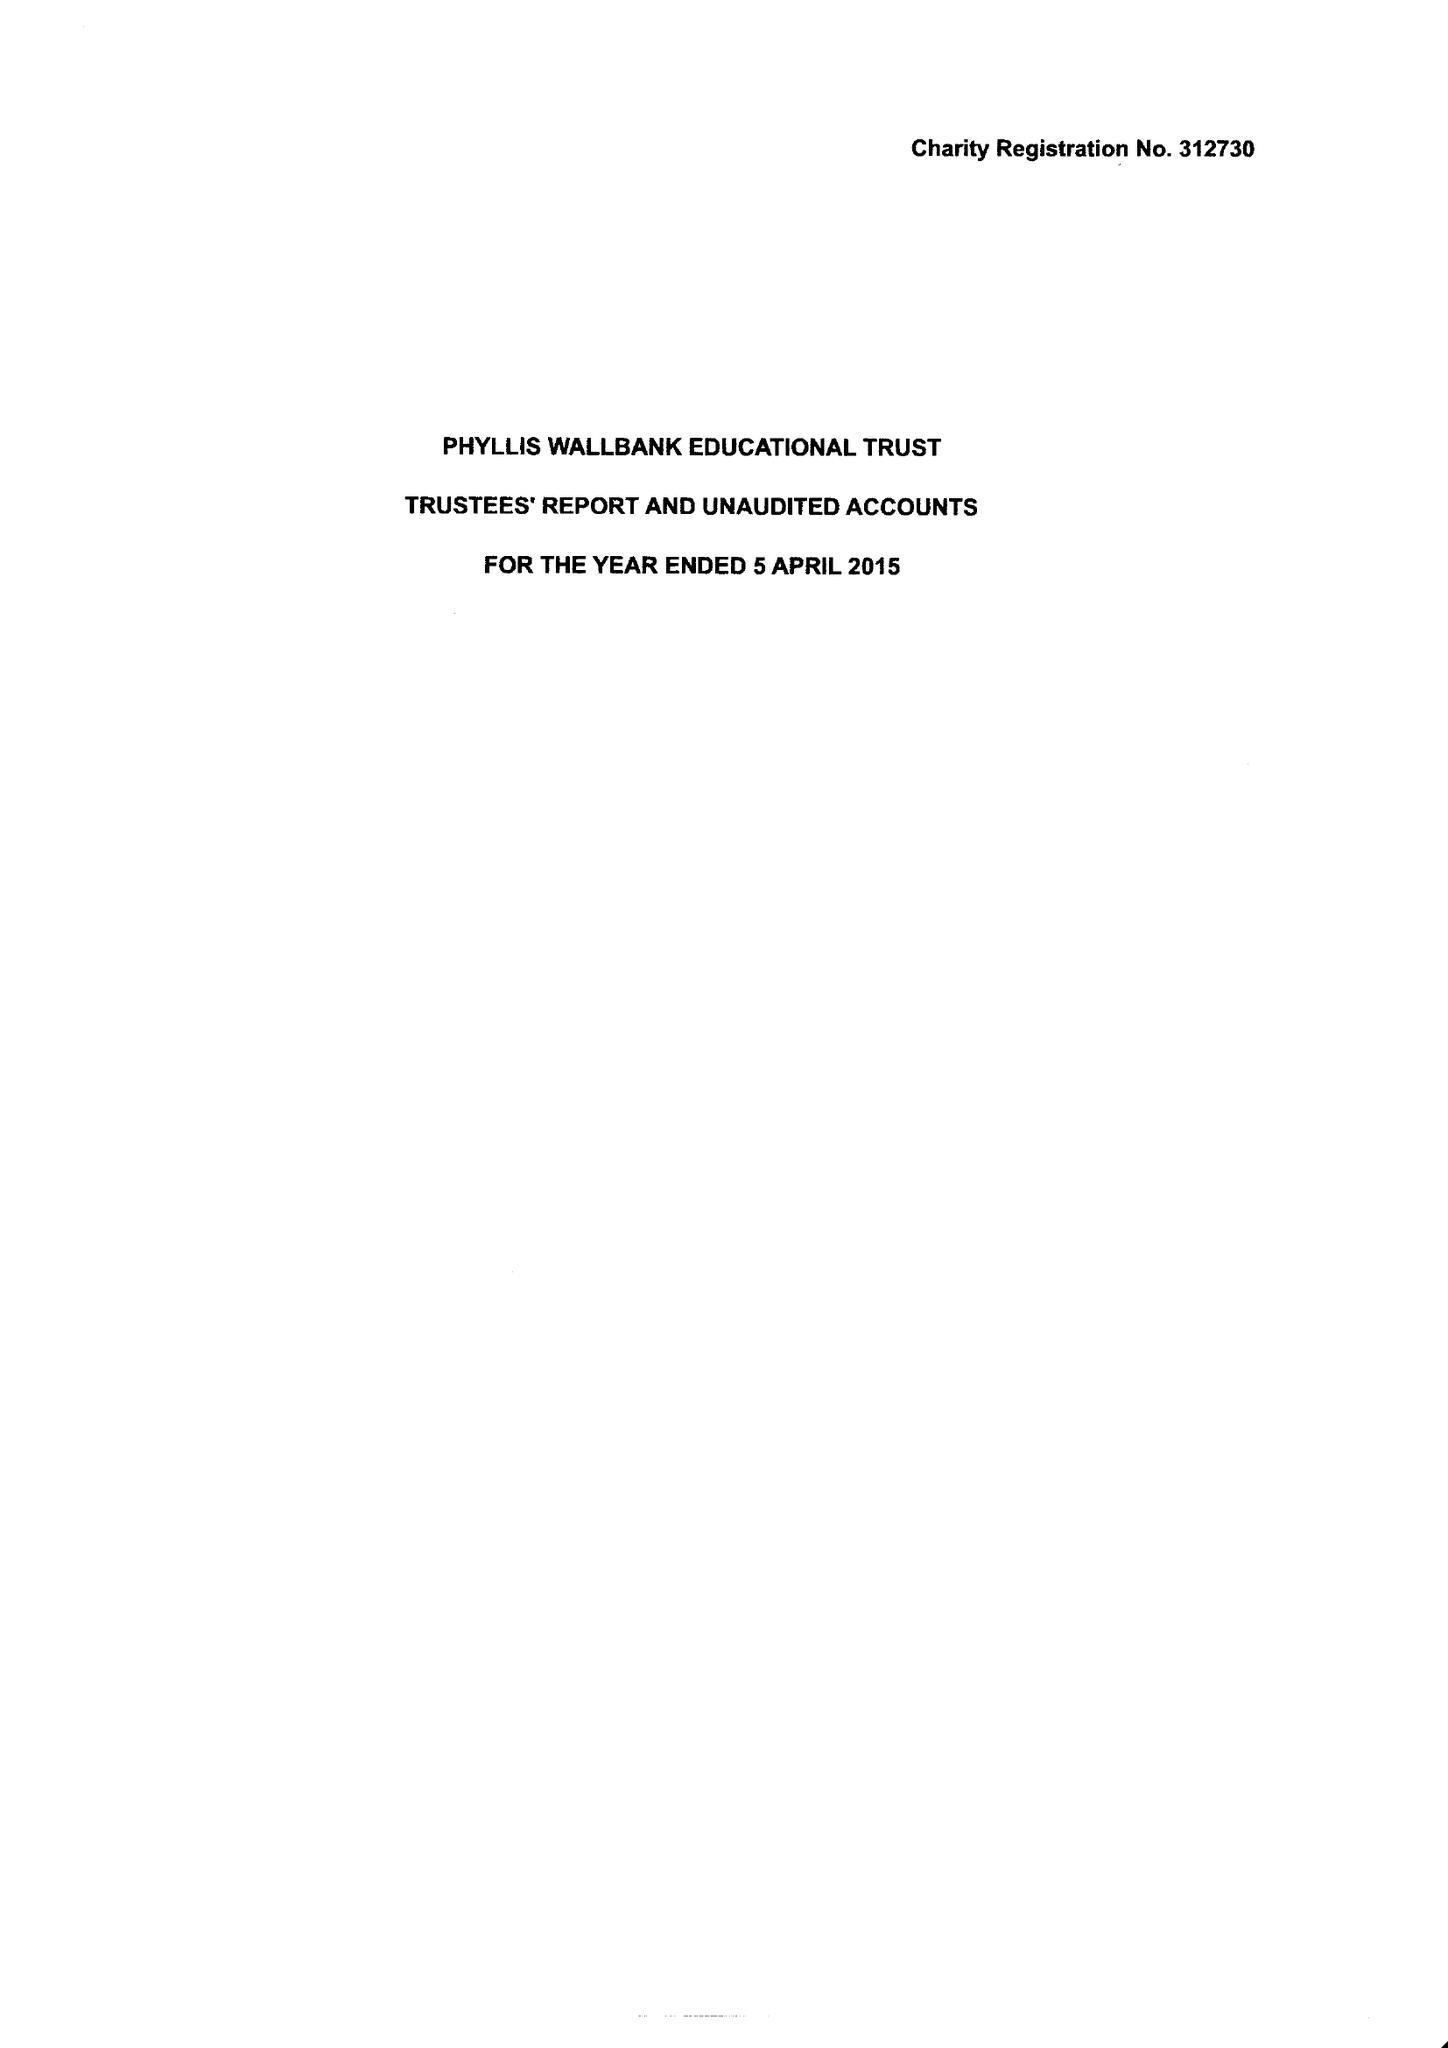What is the value for the address__street_line?
Answer the question using a single word or phrase. 158 AGAR GROVE 